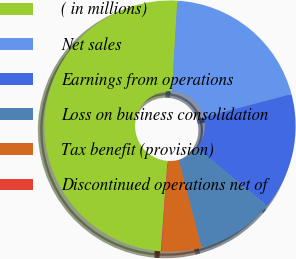<chart> <loc_0><loc_0><loc_500><loc_500><pie_chart><fcel>( in millions)<fcel>Net sales<fcel>Earnings from operations<fcel>Loss on business consolidation<fcel>Tax benefit (provision)<fcel>Discontinued operations net of<nl><fcel>49.77%<fcel>19.98%<fcel>15.01%<fcel>10.05%<fcel>5.08%<fcel>0.11%<nl></chart> 